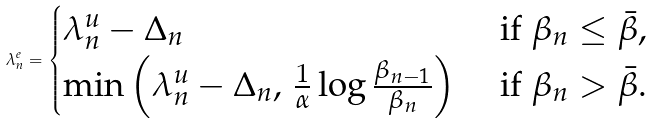<formula> <loc_0><loc_0><loc_500><loc_500>\lambda _ { n } ^ { e } = \begin{cases} \lambda _ { n } ^ { u } - \Delta _ { n } & \text { if } \beta _ { n } \leq \bar { \beta } , \\ \min \left ( \lambda _ { n } ^ { u } - \Delta _ { n } , \, \frac { 1 } { \alpha } \log \frac { \beta _ { n - 1 } } { \beta _ { n } } \right ) & \text { if } \beta _ { n } > \bar { \beta } . \end{cases}</formula> 